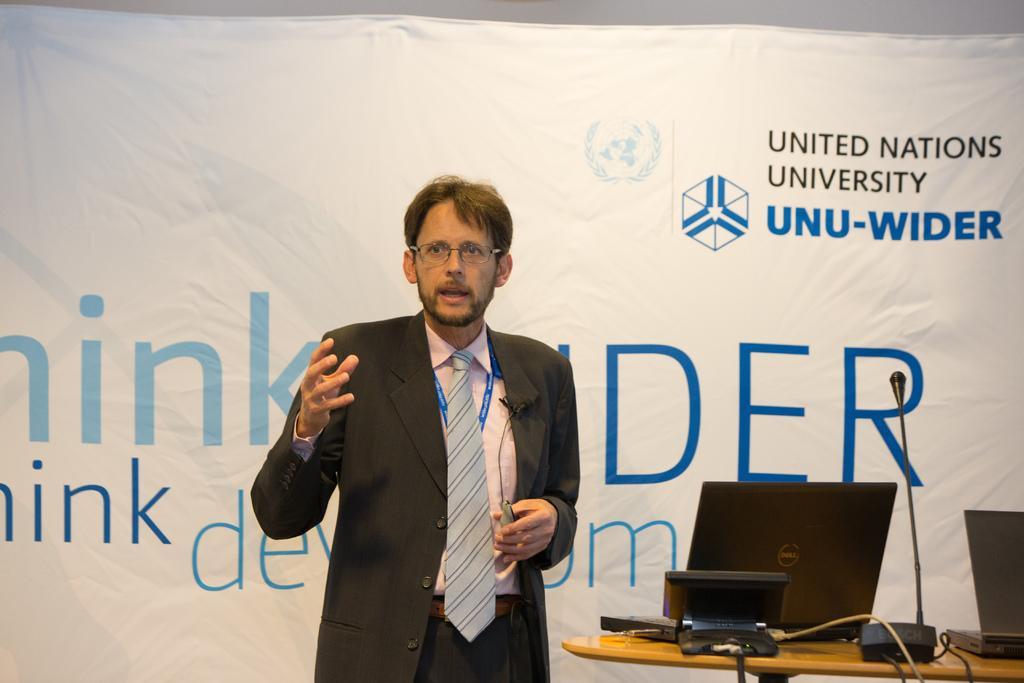Please provide a concise description of this image. In this image we can see a person standing and holding an object. There are few laptops and few other objects placed on the table at the right side of the image. There is a banner and some text printed on it. 